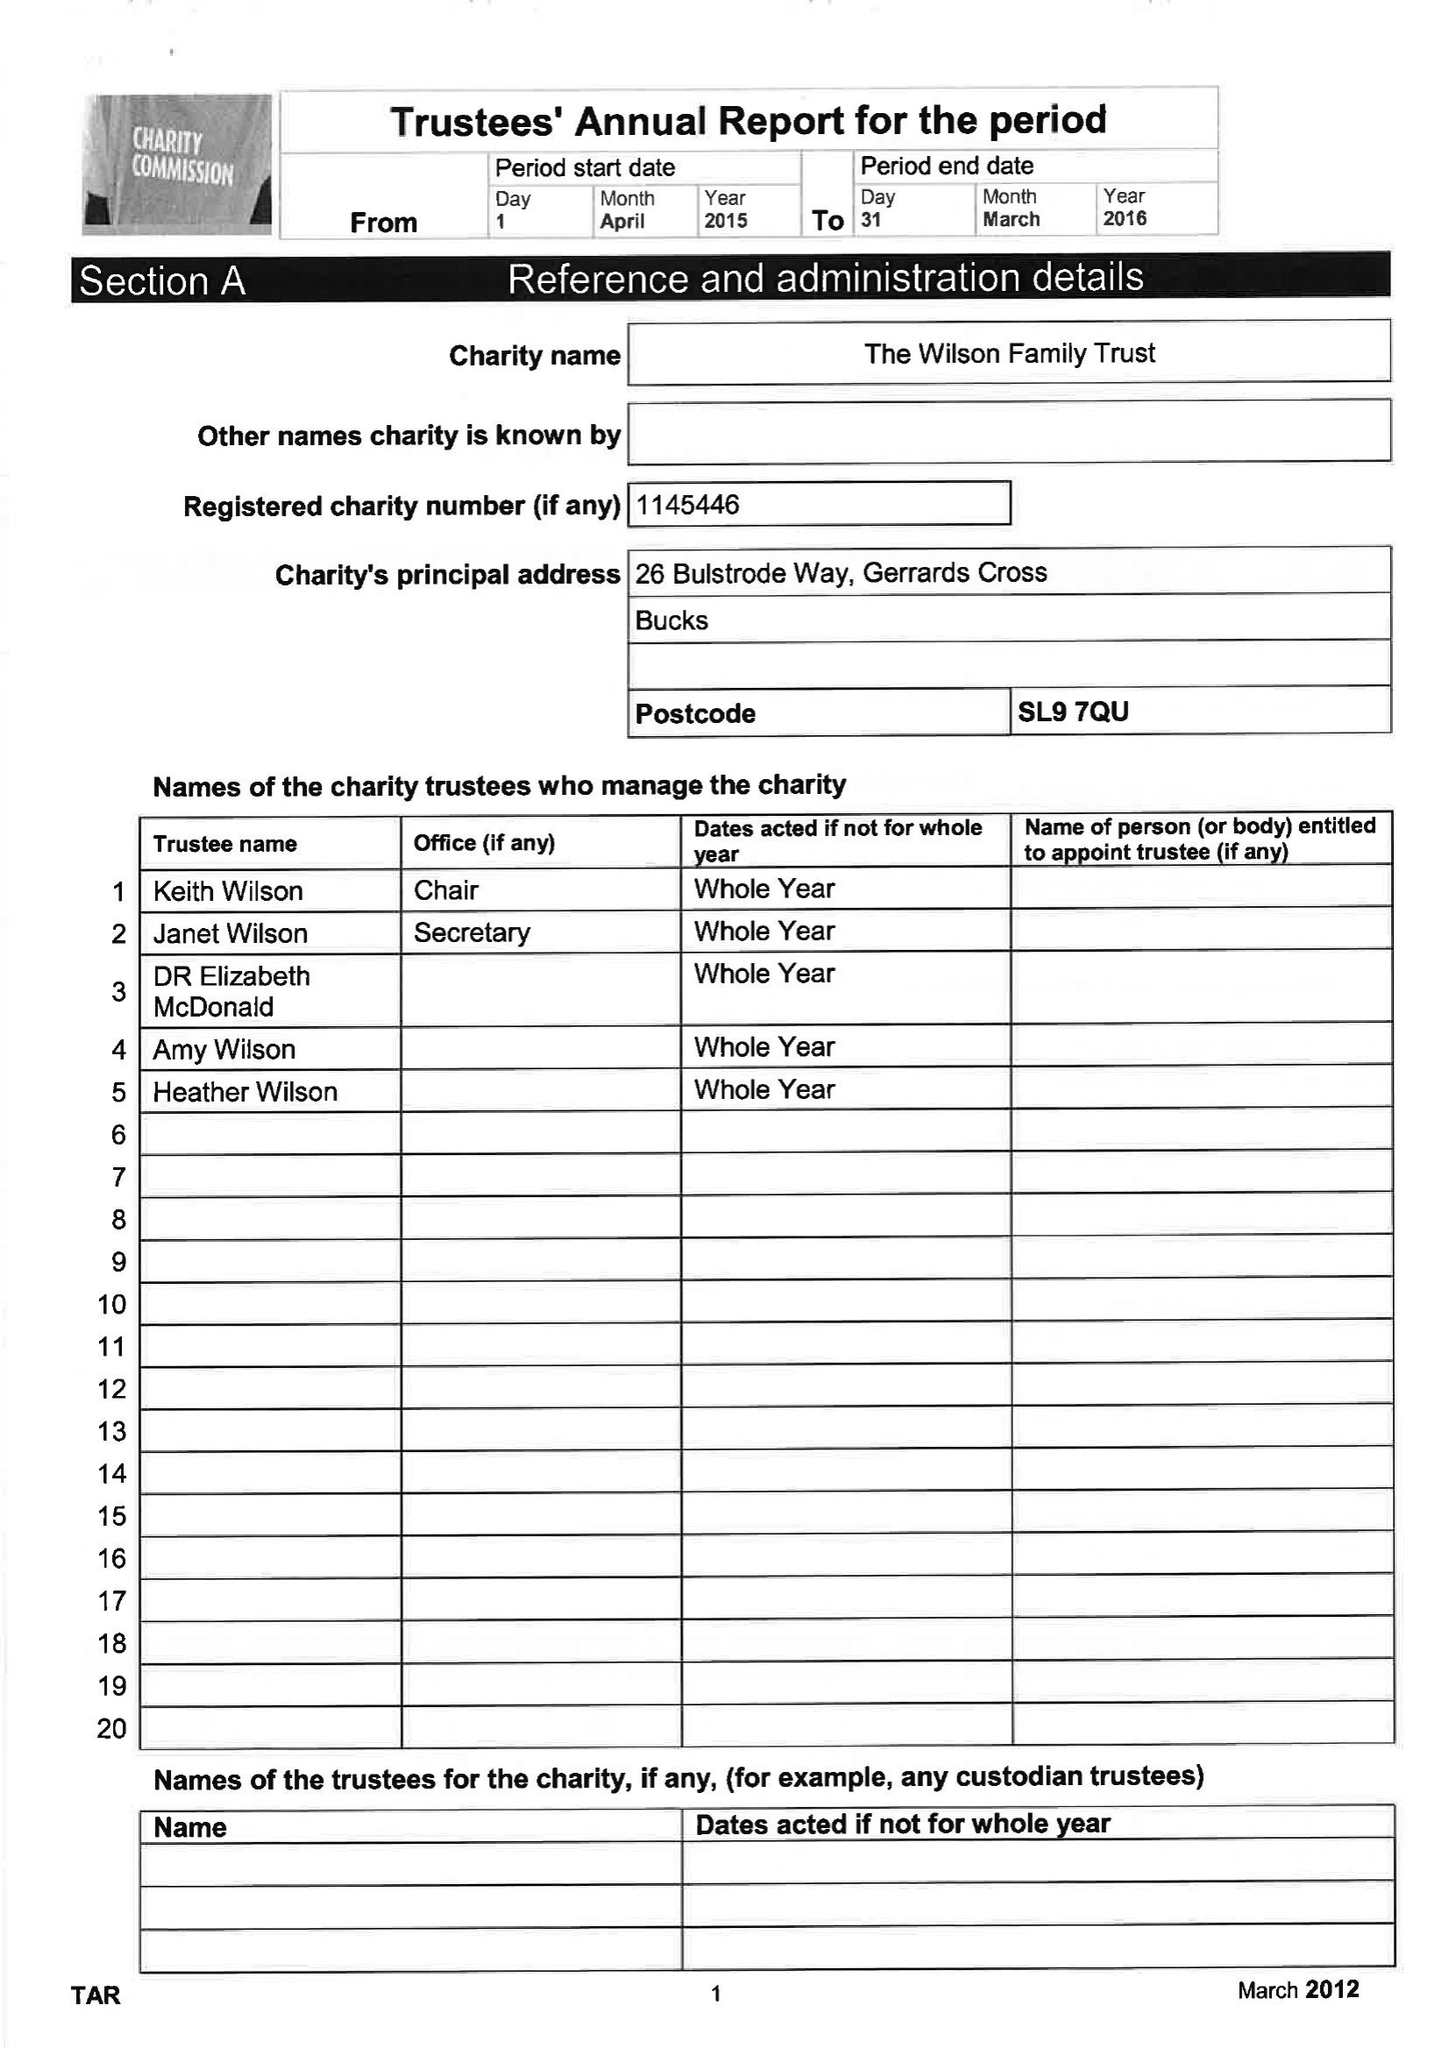What is the value for the charity_number?
Answer the question using a single word or phrase. 1145446 